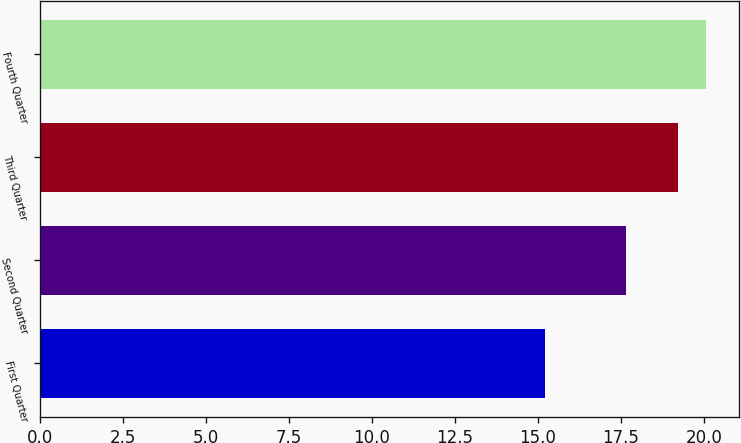Convert chart. <chart><loc_0><loc_0><loc_500><loc_500><bar_chart><fcel>First Quarter<fcel>Second Quarter<fcel>Third Quarter<fcel>Fourth Quarter<nl><fcel>15.21<fcel>17.65<fcel>19.23<fcel>20.07<nl></chart> 